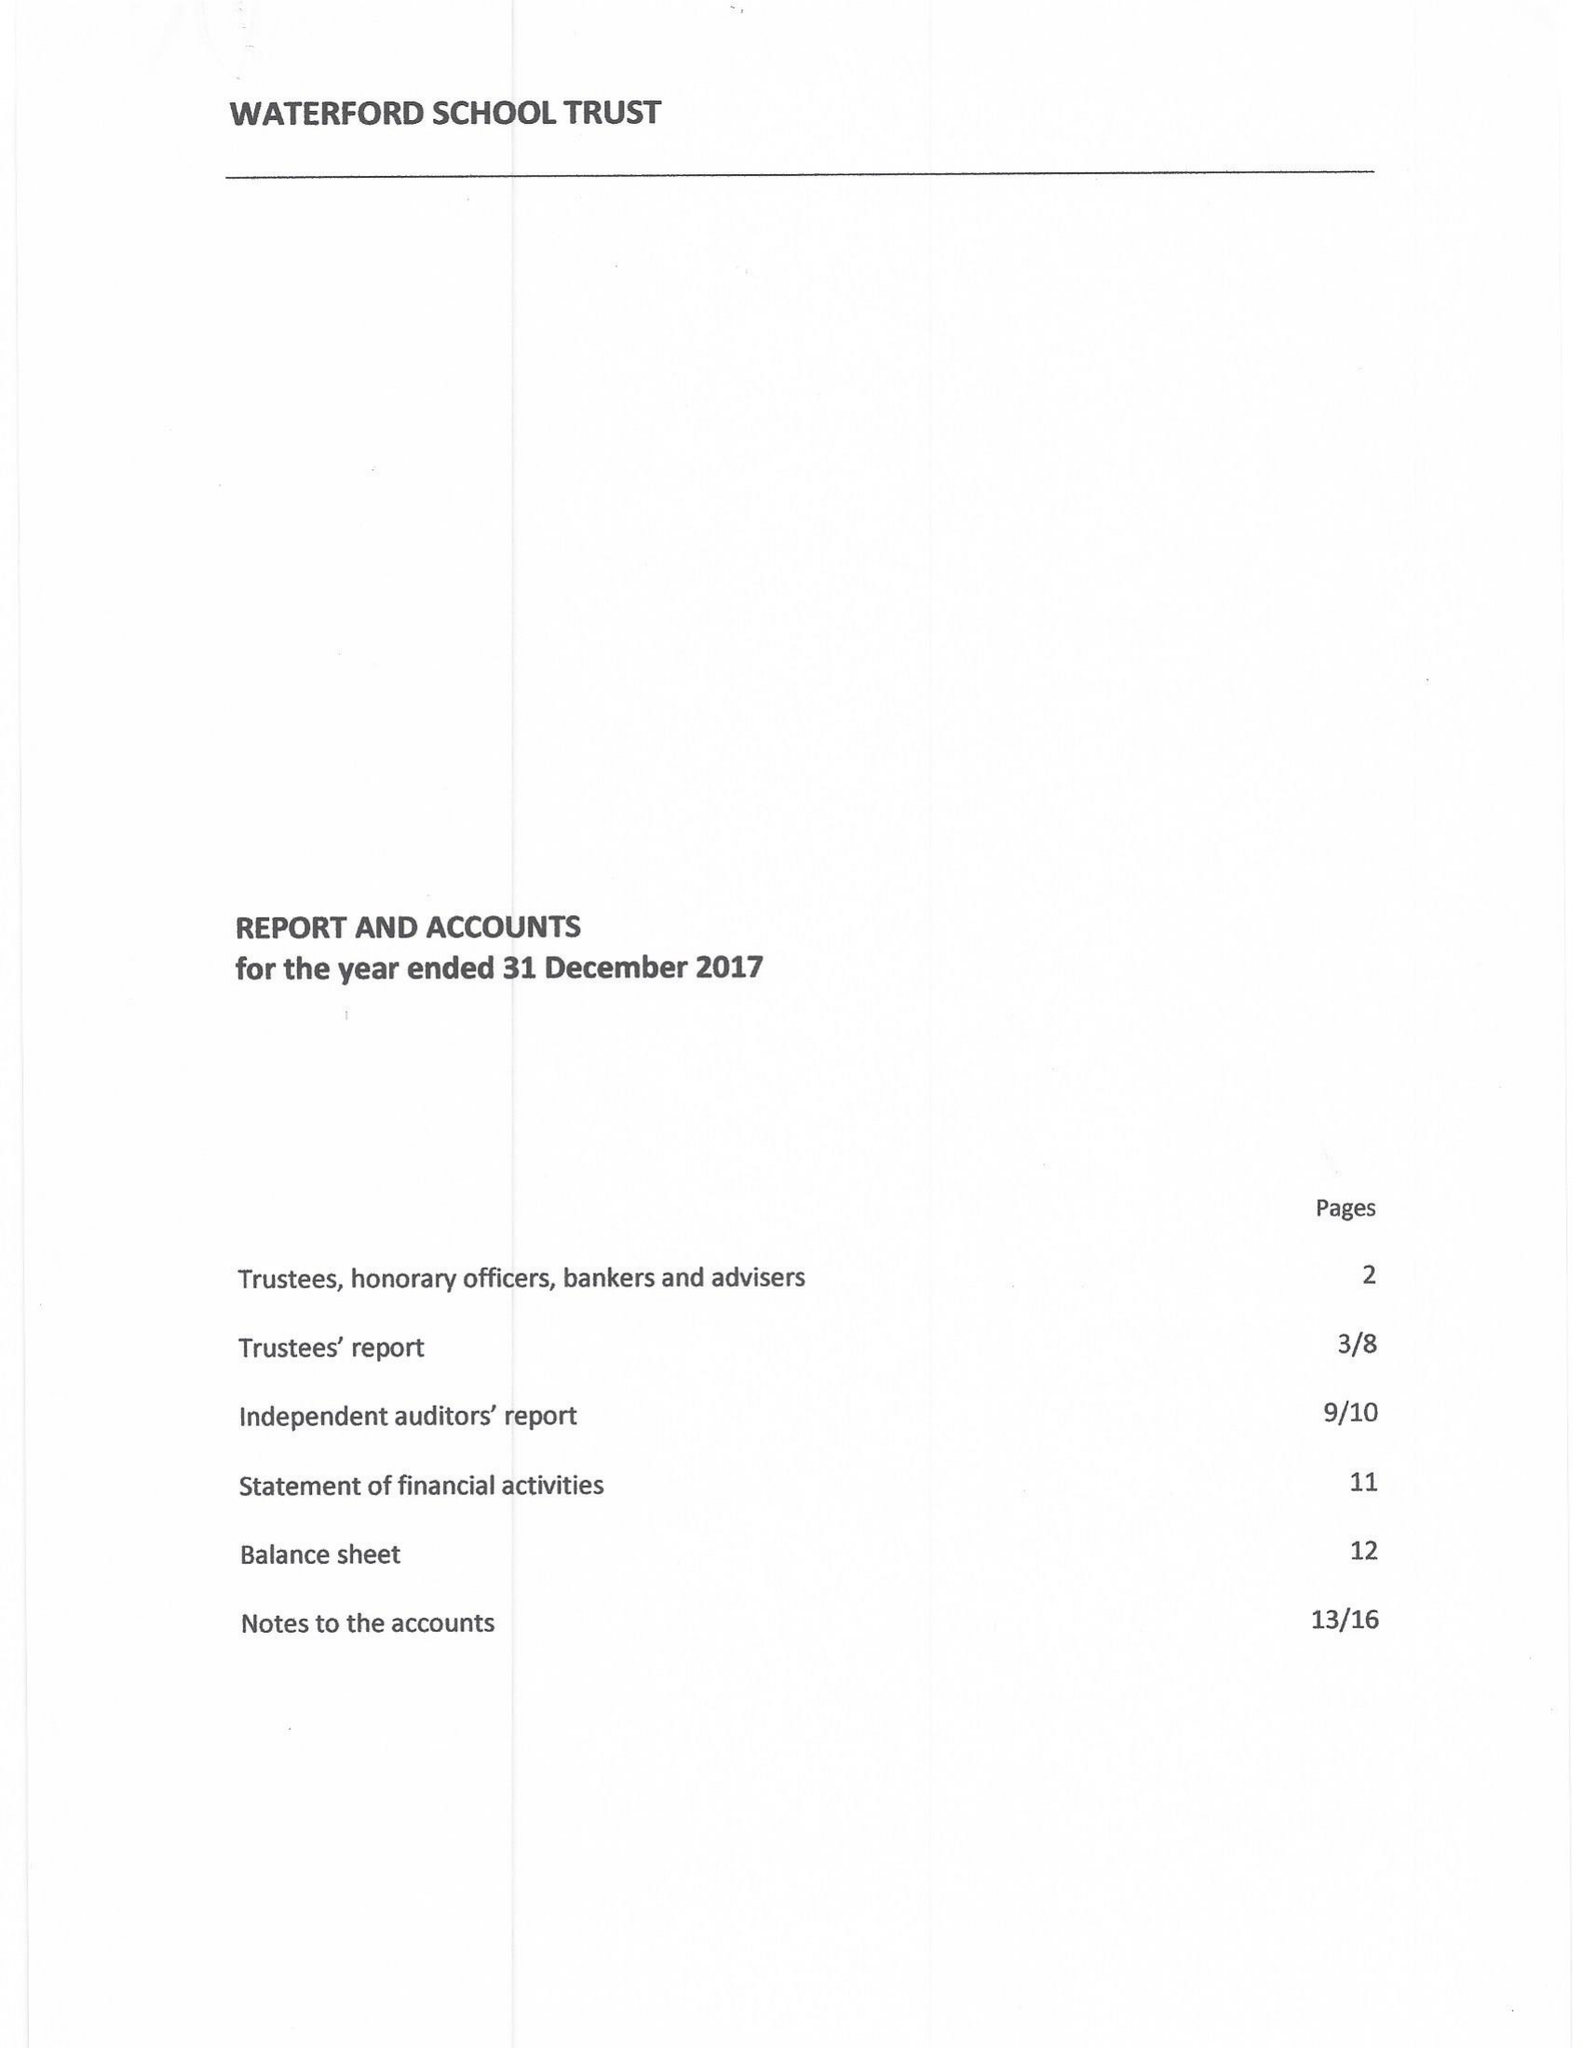What is the value for the spending_annually_in_british_pounds?
Answer the question using a single word or phrase. 57398.00 